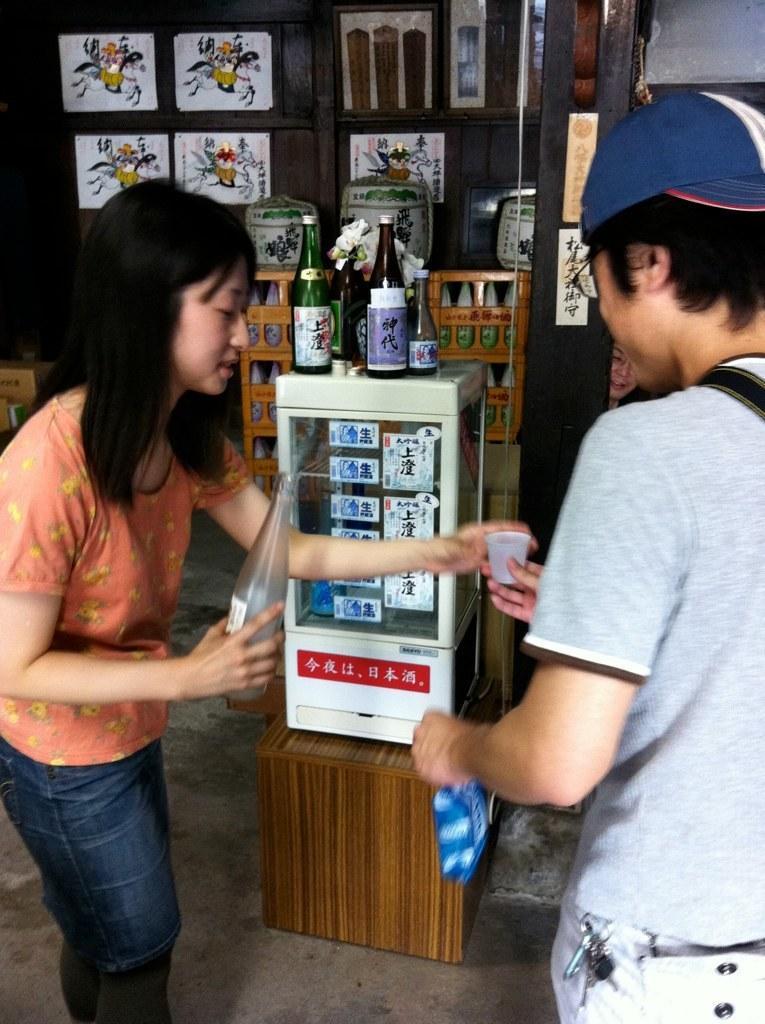In one or two sentences, can you explain what this image depicts? In this image, we can see a woman and man are holding few objects. Background we can see some boxes, wooden objects, bottles, posters, person and wall. At the bottom, there is a floor. 